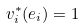<formula> <loc_0><loc_0><loc_500><loc_500>v _ { i } ^ { * } ( e _ { i } ) = 1</formula> 